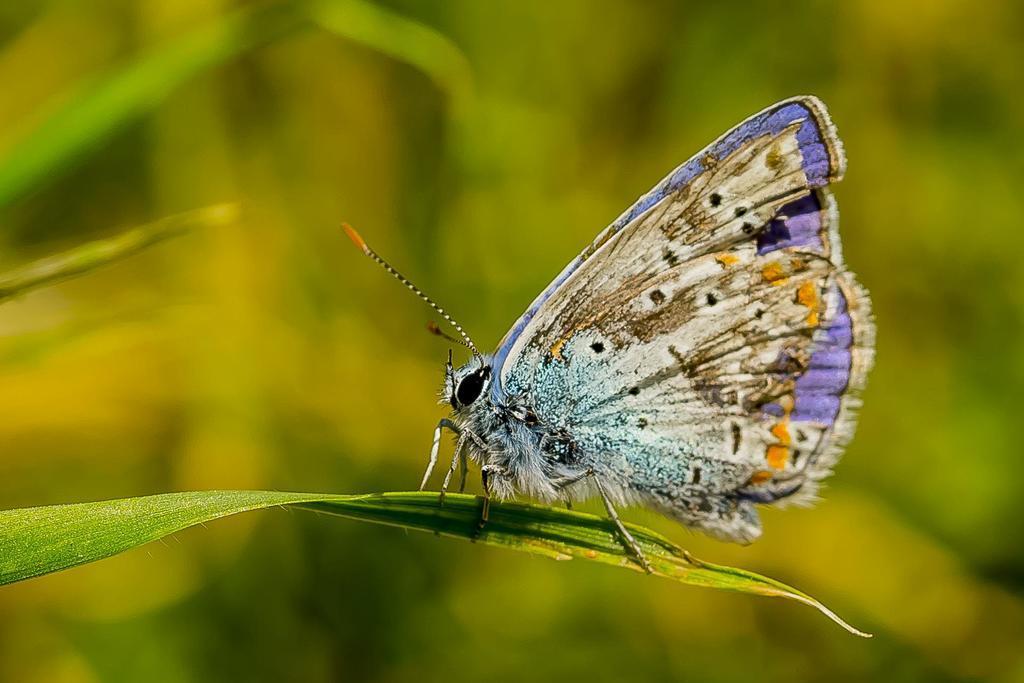In one or two sentences, can you explain what this image depicts? In the center of the image we can see butterfly on the plant. 